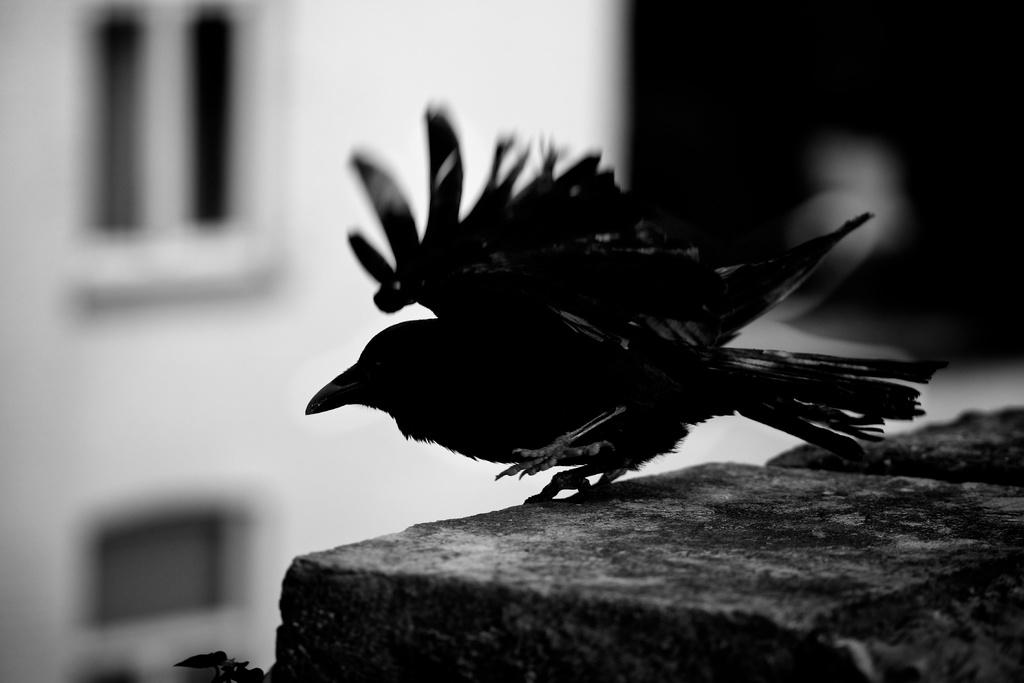What type of animal is in the image? There is a bird in the image. What color is the bird? The bird is black in color. What is at the bottom of the image? There is a wall at the bottom of the image. What can be seen in the background of the image? There is a building and a window visible in the background of the image. What type of legal advice is the bird providing to the fireman in the image? There is no fireman or legal advice present in the image; it features a black bird and a wall with a building and window in the background. 